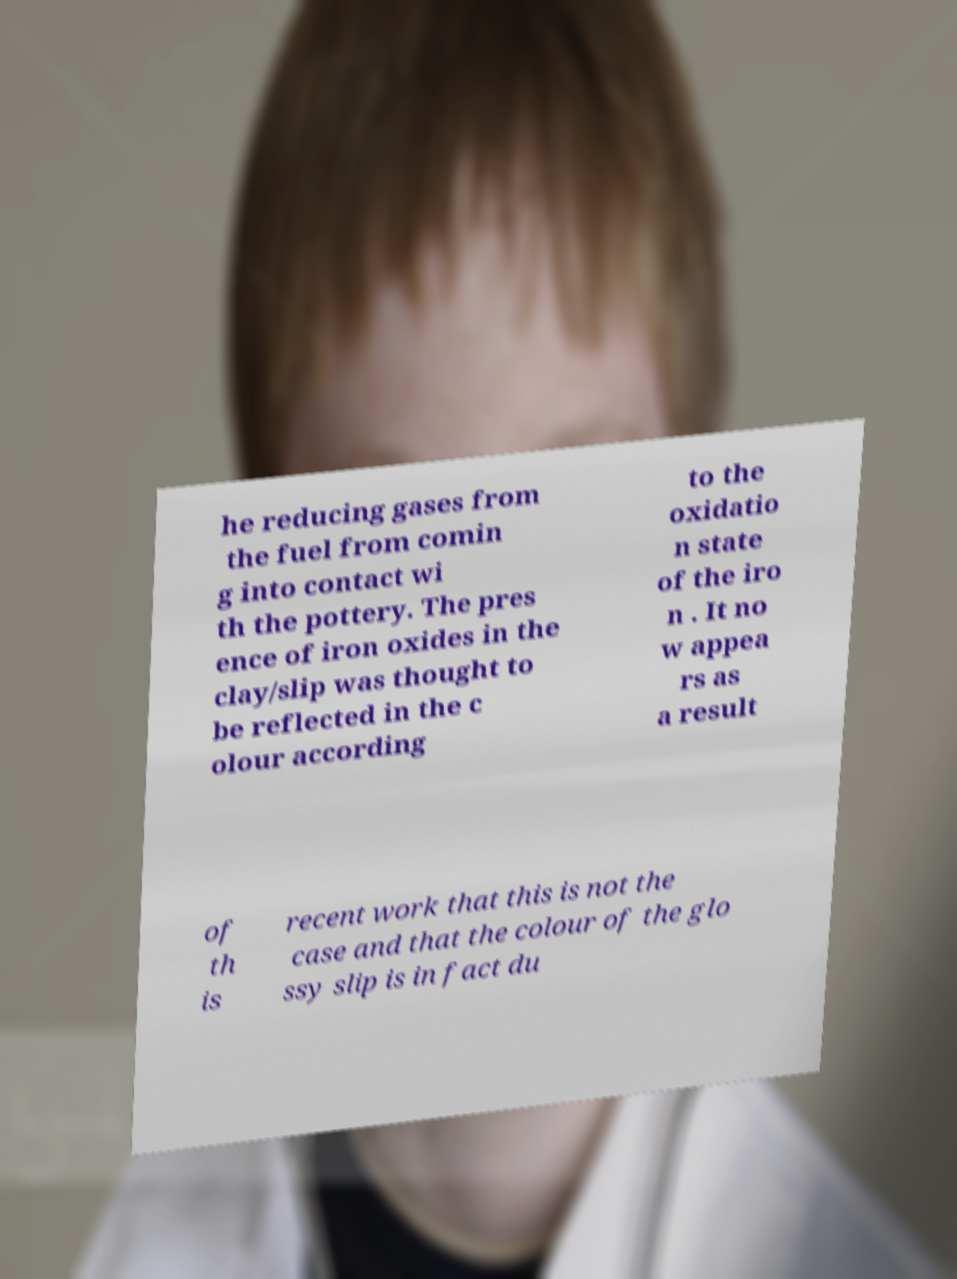What messages or text are displayed in this image? I need them in a readable, typed format. he reducing gases from the fuel from comin g into contact wi th the pottery. The pres ence of iron oxides in the clay/slip was thought to be reflected in the c olour according to the oxidatio n state of the iro n . It no w appea rs as a result of th is recent work that this is not the case and that the colour of the glo ssy slip is in fact du 